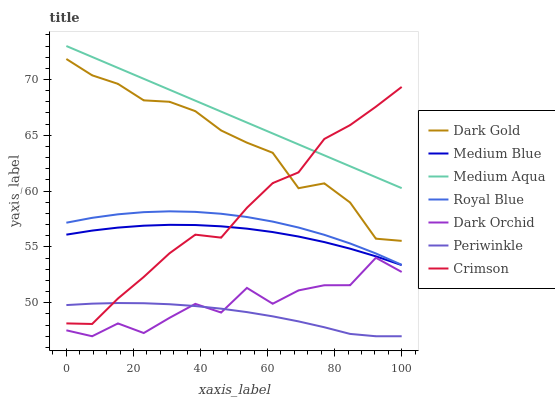Does Periwinkle have the minimum area under the curve?
Answer yes or no. Yes. Does Medium Aqua have the maximum area under the curve?
Answer yes or no. Yes. Does Medium Blue have the minimum area under the curve?
Answer yes or no. No. Does Medium Blue have the maximum area under the curve?
Answer yes or no. No. Is Medium Aqua the smoothest?
Answer yes or no. Yes. Is Dark Orchid the roughest?
Answer yes or no. Yes. Is Medium Blue the smoothest?
Answer yes or no. No. Is Medium Blue the roughest?
Answer yes or no. No. Does Dark Orchid have the lowest value?
Answer yes or no. Yes. Does Medium Blue have the lowest value?
Answer yes or no. No. Does Medium Aqua have the highest value?
Answer yes or no. Yes. Does Medium Blue have the highest value?
Answer yes or no. No. Is Royal Blue less than Dark Gold?
Answer yes or no. Yes. Is Medium Aqua greater than Dark Gold?
Answer yes or no. Yes. Does Periwinkle intersect Dark Orchid?
Answer yes or no. Yes. Is Periwinkle less than Dark Orchid?
Answer yes or no. No. Is Periwinkle greater than Dark Orchid?
Answer yes or no. No. Does Royal Blue intersect Dark Gold?
Answer yes or no. No. 